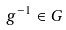Convert formula to latex. <formula><loc_0><loc_0><loc_500><loc_500>g ^ { - 1 } \in G</formula> 